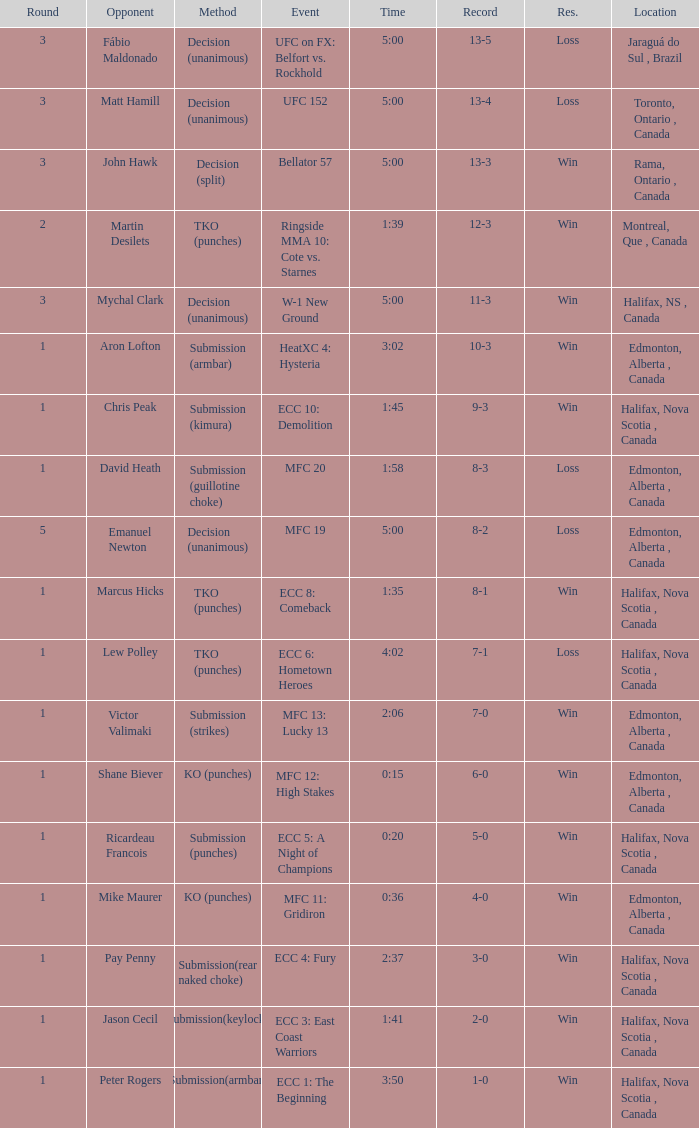What is the location of the match with Aron Lofton as the opponent? Edmonton, Alberta , Canada. 